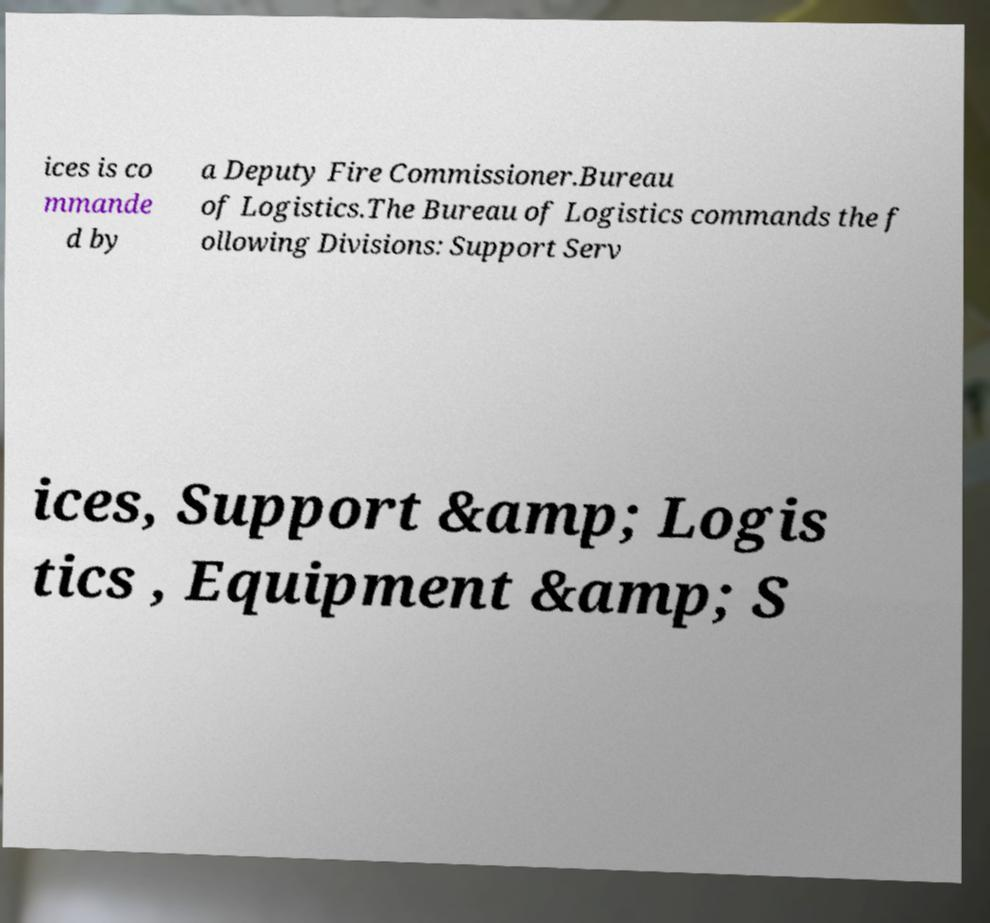Please identify and transcribe the text found in this image. ices is co mmande d by a Deputy Fire Commissioner.Bureau of Logistics.The Bureau of Logistics commands the f ollowing Divisions: Support Serv ices, Support &amp; Logis tics , Equipment &amp; S 